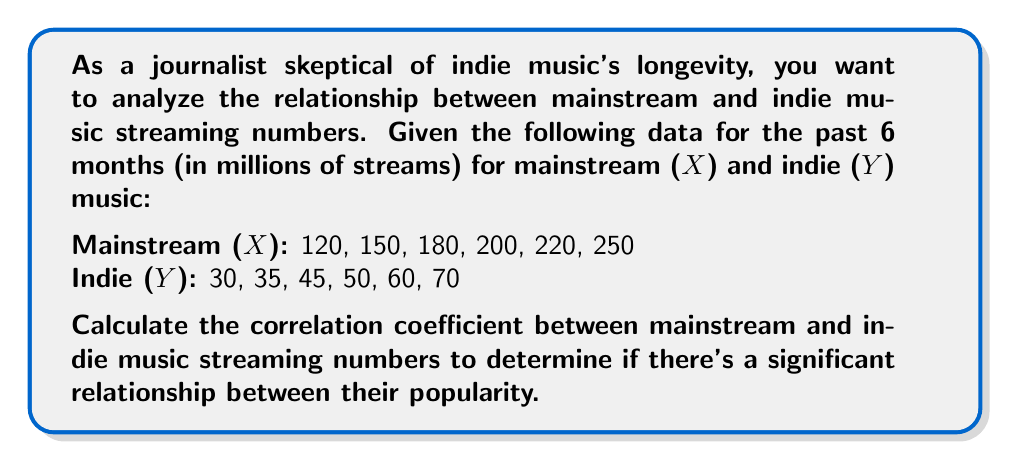What is the answer to this math problem? To calculate the correlation coefficient, we'll use the Pearson correlation formula:

$$ r = \frac{\sum_{i=1}^{n} (x_i - \bar{x})(y_i - \bar{y})}{\sqrt{\sum_{i=1}^{n} (x_i - \bar{x})^2 \sum_{i=1}^{n} (y_i - \bar{y})^2}} $$

Step 1: Calculate the means $\bar{x}$ and $\bar{y}$
$\bar{x} = \frac{120 + 150 + 180 + 200 + 220 + 250}{6} = 186.67$
$\bar{y} = \frac{30 + 35 + 45 + 50 + 60 + 70}{6} = 48.33$

Step 2: Calculate $(x_i - \bar{x})$, $(y_i - \bar{y})$, $(x_i - \bar{x})^2$, $(y_i - \bar{y})^2$, and $(x_i - \bar{x})(y_i - \bar{y})$

| $x_i$ | $y_i$ | $x_i - \bar{x}$ | $y_i - \bar{y}$ | $(x_i - \bar{x})^2$ | $(y_i - \bar{y})^2$ | $(x_i - \bar{x})(y_i - \bar{y})$ |
|-------|-------|-----------------|-----------------|---------------------|---------------------|----------------------------------|
| 120   | 30    | -66.67          | -18.33          | 4444.89             | 336.00              | 1222.07                          |
| 150   | 35    | -36.67          | -13.33          | 1344.69             | 177.78              | 488.81                           |
| 180   | 45    | -6.67           | -3.33           | 44.49               | 11.11               | 22.21                            |
| 200   | 50    | 13.33           | 1.67            | 177.69              | 2.78                | 22.26                            |
| 220   | 60    | 33.33           | 11.67           | 1110.89             | 136.11              | 388.96                           |
| 250   | 70    | 63.33           | 21.67           | 4010.69             | 469.44              | 1372.36                          |

Step 3: Sum up the columns
$\sum (x_i - \bar{x})^2 = 11133.34$
$\sum (y_i - \bar{y})^2 = 1133.22$
$\sum (x_i - \bar{x})(y_i - \bar{y}) = 3516.67$

Step 4: Apply the correlation coefficient formula
$$ r = \frac{3516.67}{\sqrt{11133.34 \times 1133.22}} = \frac{3516.67}{3551.87} = 0.9901 $$
Answer: The correlation coefficient between mainstream and indie music streaming numbers is approximately 0.9901. 